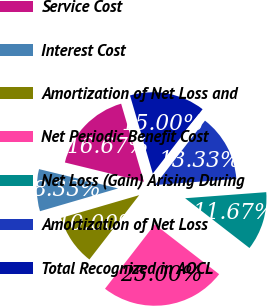Convert chart. <chart><loc_0><loc_0><loc_500><loc_500><pie_chart><fcel>Service Cost<fcel>Interest Cost<fcel>Amortization of Net Loss and<fcel>Net Periodic Benefit Cost<fcel>Net Loss (Gain) Arising During<fcel>Amortization of Net Loss<fcel>Total Recognized in AOCL<nl><fcel>16.67%<fcel>8.33%<fcel>10.0%<fcel>25.0%<fcel>11.67%<fcel>13.33%<fcel>15.0%<nl></chart> 